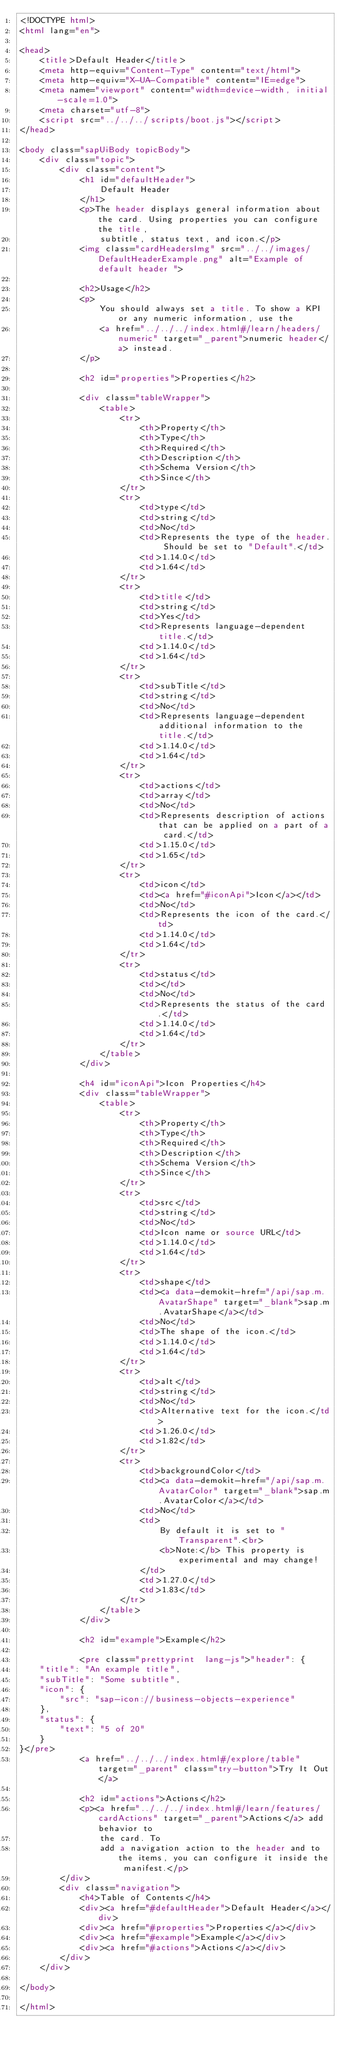Convert code to text. <code><loc_0><loc_0><loc_500><loc_500><_HTML_><!DOCTYPE html>
<html lang="en">

<head>
	<title>Default Header</title>
	<meta http-equiv="Content-Type" content="text/html">
	<meta http-equiv="X-UA-Compatible" content="IE=edge">
	<meta name="viewport" content="width=device-width, initial-scale=1.0">
	<meta charset="utf-8">
	<script src="../../../scripts/boot.js"></script>
</head>

<body class="sapUiBody topicBody">
	<div class="topic">
		<div class="content">
			<h1 id="defaultHeader">
				Default Header
			</h1>
			<p>The header displays general information about the card. Using properties you can configure the title,
				subtitle, status text, and icon.</p>
			<img class="cardHeadersImg" src="../../images/DefaultHeaderExample.png" alt="Example of default header ">

			<h2>Usage</h2>
			<p>
				You should always set a title. To show a KPI or any numeric information, use the
				<a href="../../../index.html#/learn/headers/numeric" target="_parent">numeric header</a> instead.
			</p>

			<h2 id="properties">Properties</h2>

			<div class="tableWrapper">
				<table>
					<tr>
						<th>Property</th>
						<th>Type</th>
						<th>Required</th>
						<th>Description</th>
						<th>Schema Version</th>
						<th>Since</th>
					</tr>
					<tr>
						<td>type</td>
						<td>string</td>
						<td>No</td>
						<td>Represents the type of the header. Should be set to "Default".</td>
						<td>1.14.0</td>
						<td>1.64</td>
					</tr>
					<tr>
						<td>title</td>
						<td>string</td>
						<td>Yes</td>
						<td>Represents language-dependent title.</td>
						<td>1.14.0</td>
						<td>1.64</td>
					</tr>
					<tr>
						<td>subTitle</td>
						<td>string</td>
						<td>No</td>
						<td>Represents language-dependent additional information to the title.</td>
						<td>1.14.0</td>
						<td>1.64</td>
					</tr>
					<tr>
						<td>actions</td>
						<td>array</td>
						<td>No</td>
						<td>Represents description of actions that can be applied on a part of a card.</td>
						<td>1.15.0</td>
						<td>1.65</td>
					</tr>
					<tr>
						<td>icon</td>
						<td><a href="#iconApi">Icon</a></td>
						<td>No</td>
						<td>Represents the icon of the card.</td>
						<td>1.14.0</td>
						<td>1.64</td>
					</tr>
					<tr>
						<td>status</td>
						<td></td>
						<td>No</td>
						<td>Represents the status of the card.</td>
						<td>1.14.0</td>
						<td>1.64</td>
					</tr>
				</table>
			</div>

			<h4 id="iconApi">Icon Properties</h4>
			<div class="tableWrapper">
				<table>
					<tr>
						<th>Property</th>
						<th>Type</th>
						<th>Required</th>
						<th>Description</th>
						<th>Schema Version</th>
						<th>Since</th>
					</tr>
					<tr>
						<td>src</td>
						<td>string</td>
						<td>No</td>
						<td>Icon name or source URL</td>
						<td>1.14.0</td>
						<td>1.64</td>
					</tr>
					<tr>
						<td>shape</td>
						<td><a data-demokit-href="/api/sap.m.AvatarShape" target="_blank">sap.m.AvatarShape</a></td>
						<td>No</td>
						<td>The shape of the icon.</td>
						<td>1.14.0</td>
						<td>1.64</td>
					</tr>
					<tr>
						<td>alt</td>
						<td>string</td>
						<td>No</td>
						<td>Alternative text for the icon.</td>
						<td>1.26.0</td>
						<td>1.82</td>
					</tr>
					<tr>
						<td>backgroundColor</td>
						<td><a data-demokit-href="/api/sap.m.AvatarColor" target="_blank">sap.m.AvatarColor</a></td>
						<td>No</td>
						<td>
							By default it is set to "Transparent".<br>
							<b>Note:</b> This property is experimental and may change!
						</td>
						<td>1.27.0</td>
						<td>1.83</td>
					</tr>
				</table>
			</div>

			<h2 id="example">Example</h2>

			<pre class="prettyprint  lang-js">"header": {
	"title": "An example title",
	"subTitle": "Some subtitle",
	"icon": {
		"src": "sap-icon://business-objects-experience"
	},
	"status": {
		"text": "5 of 20"
	}
}</pre>
			<a href="../../../index.html#/explore/table" target="_parent" class="try-button">Try It Out</a>

			<h2 id="actions">Actions</h2>
			<p><a href="../../../index.html#/learn/features/cardActions" target="_parent">Actions</a> add behavior to
				the card. To
				add a navigation action to the header and to the items, you can configure it inside the manifest.</p>
		</div>
		<div class="navigation">
			<h4>Table of Contents</h4>
			<div><a href="#defaultHeader">Default Header</a></div>
			<div><a href="#properties">Properties</a></div>
			<div><a href="#example">Example</a></div>
			<div><a href="#actions">Actions</a></div>
		</div>
	</div>

</body>

</html></code> 